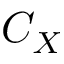<formula> <loc_0><loc_0><loc_500><loc_500>C _ { X }</formula> 